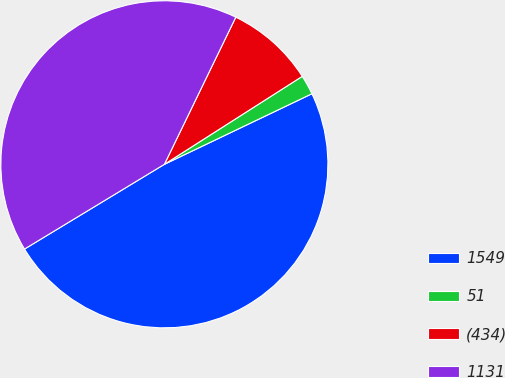Convert chart. <chart><loc_0><loc_0><loc_500><loc_500><pie_chart><fcel>1549<fcel>51<fcel>(434)<fcel>1131<nl><fcel>48.43%<fcel>1.94%<fcel>8.77%<fcel>40.86%<nl></chart> 